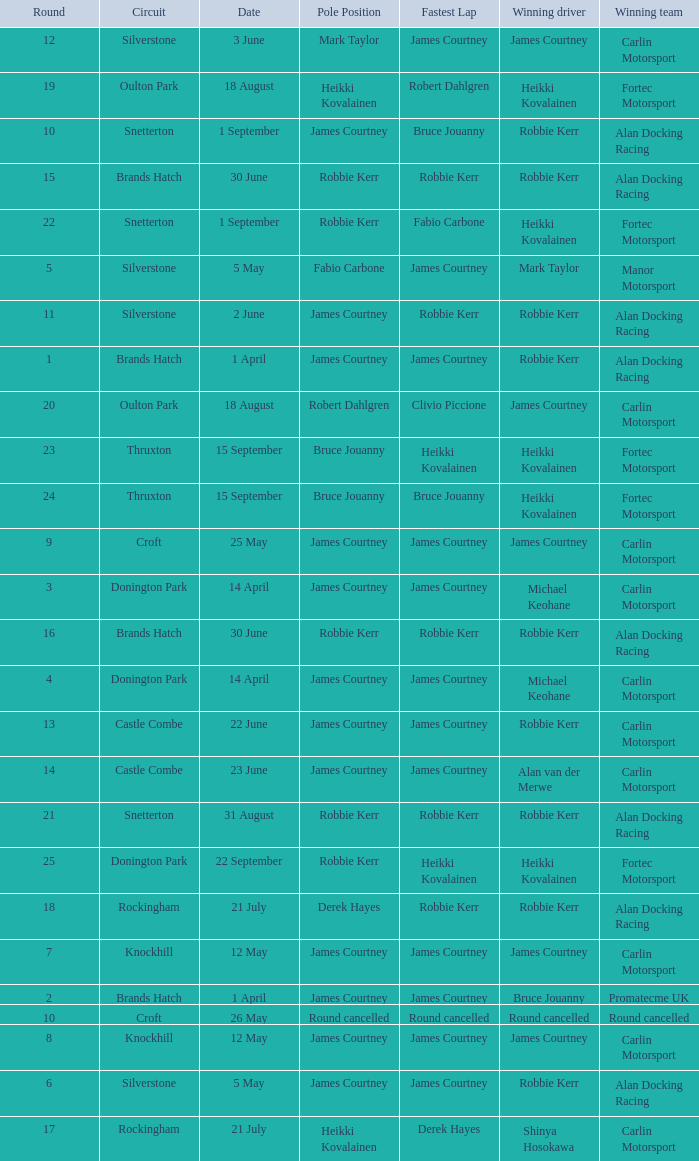Who are all winning drivers if winning team is Carlin Motorsport and circuit is Croft? James Courtney. 